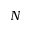Convert formula to latex. <formula><loc_0><loc_0><loc_500><loc_500>N</formula> 